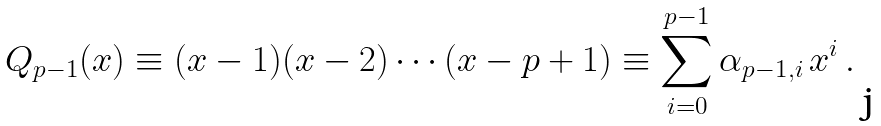Convert formula to latex. <formula><loc_0><loc_0><loc_500><loc_500>Q _ { p - 1 } ( x ) \equiv ( x - 1 ) ( x - 2 ) \cdots ( x - p + 1 ) \equiv \sum _ { i = 0 } ^ { p - 1 } \alpha _ { p - 1 , i } \, x ^ { i } \, .</formula> 